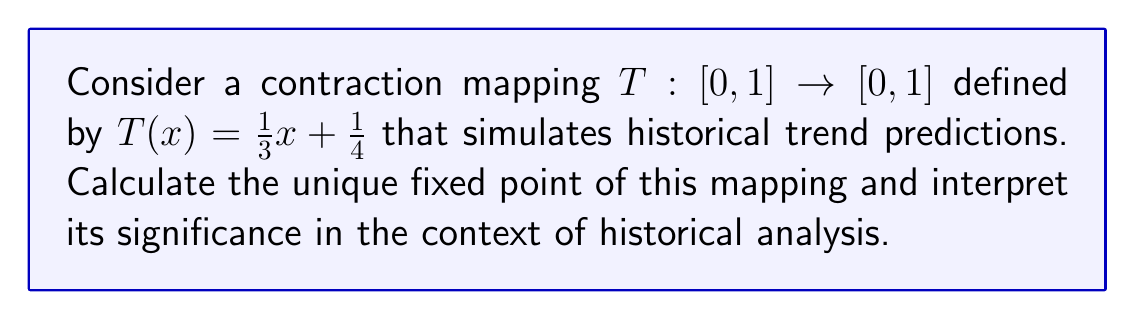Give your solution to this math problem. To find the fixed point of the contraction mapping $T(x) = \frac{1}{3}x + \frac{1}{4}$, we need to solve the equation $T(x) = x$. This gives us:

$$\frac{1}{3}x + \frac{1}{4} = x$$

Subtracting $x$ from both sides:

$$\frac{1}{3}x + \frac{1}{4} - x = 0$$

Simplifying:

$$\frac{1}{3}x - \frac{3}{3}x + \frac{1}{4} = 0$$
$$-\frac{2}{3}x + \frac{1}{4} = 0$$

Multiplying both sides by 3:

$$-2x + \frac{3}{4} = 0$$

Adding $2x$ to both sides:

$$\frac{3}{4} = 2x$$

Dividing both sides by 2:

$$x = \frac{3}{8} = 0.375$$

Therefore, the unique fixed point of this contraction mapping is $\frac{3}{8}$ or 0.375.

In the context of historical analysis, this fixed point represents a stable prediction point for historical trends. It suggests that, regardless of the starting point, repeated application of this prediction model will converge to this value. For an admissions counselor, this demonstrates the student's ability to apply mathematical concepts to historical trend analysis, showing a sophisticated understanding of both history and quantitative methods.
Answer: The unique fixed point of the contraction mapping $T(x) = \frac{1}{3}x + \frac{1}{4}$ is $x = \frac{3}{8}$ or 0.375. 